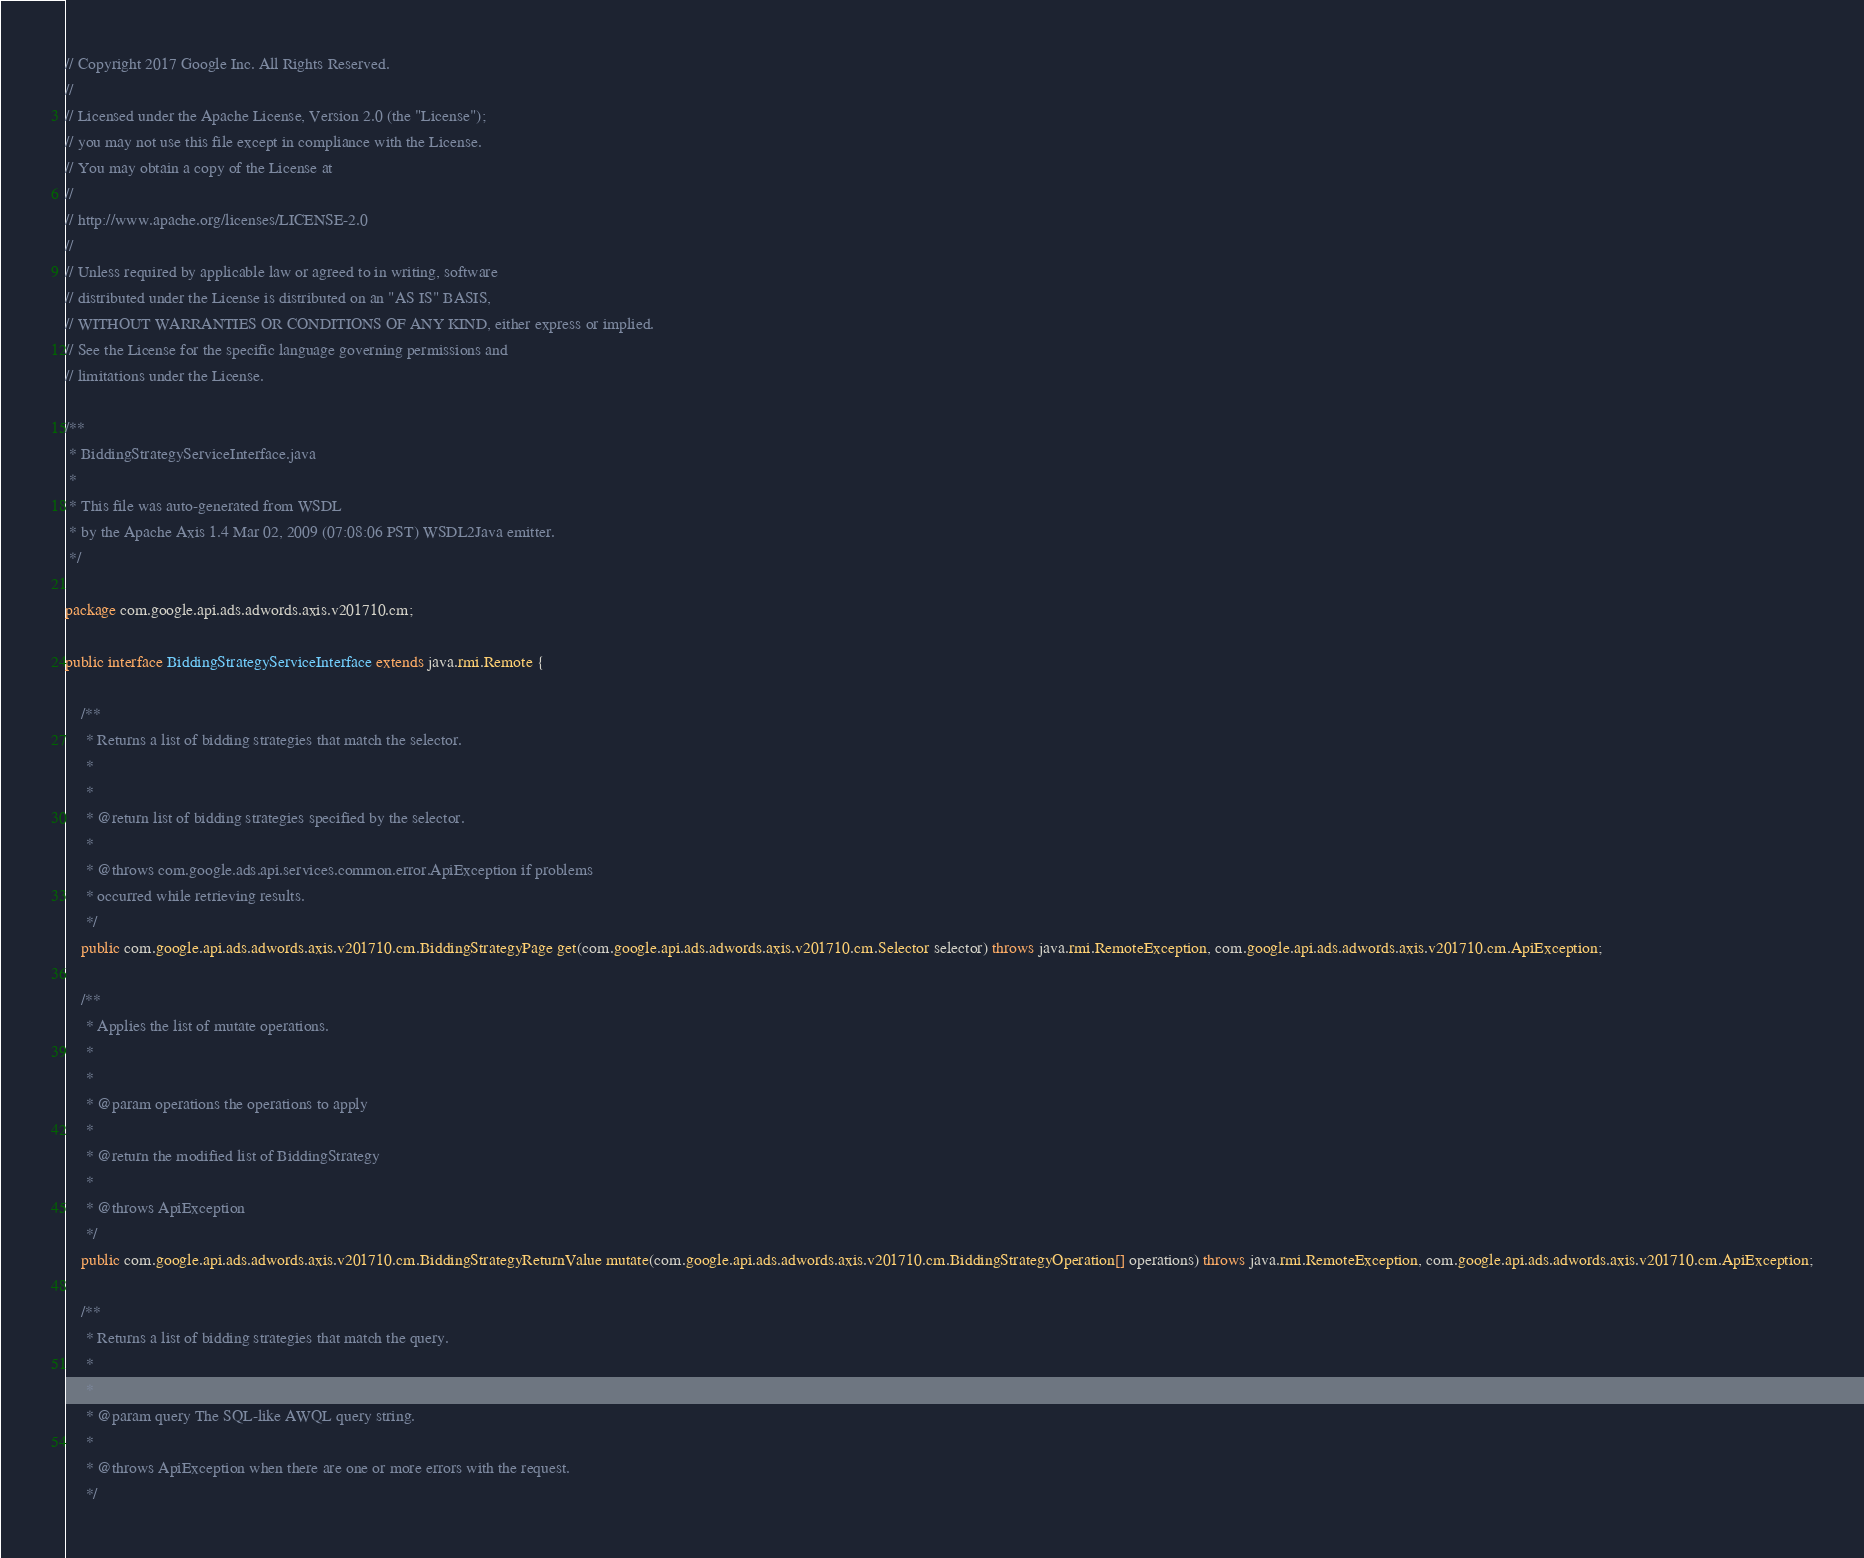Convert code to text. <code><loc_0><loc_0><loc_500><loc_500><_Java_>// Copyright 2017 Google Inc. All Rights Reserved.
//
// Licensed under the Apache License, Version 2.0 (the "License");
// you may not use this file except in compliance with the License.
// You may obtain a copy of the License at
//
// http://www.apache.org/licenses/LICENSE-2.0
//
// Unless required by applicable law or agreed to in writing, software
// distributed under the License is distributed on an "AS IS" BASIS,
// WITHOUT WARRANTIES OR CONDITIONS OF ANY KIND, either express or implied.
// See the License for the specific language governing permissions and
// limitations under the License.

/**
 * BiddingStrategyServiceInterface.java
 *
 * This file was auto-generated from WSDL
 * by the Apache Axis 1.4 Mar 02, 2009 (07:08:06 PST) WSDL2Java emitter.
 */

package com.google.api.ads.adwords.axis.v201710.cm;

public interface BiddingStrategyServiceInterface extends java.rmi.Remote {

    /**
     * Returns a list of bidding strategies that match the selector.
     * 
     *         
     * @return list of bidding strategies specified by the selector.
     *         
     * @throws com.google.ads.api.services.common.error.ApiException if problems
     * occurred while retrieving results.
     */
    public com.google.api.ads.adwords.axis.v201710.cm.BiddingStrategyPage get(com.google.api.ads.adwords.axis.v201710.cm.Selector selector) throws java.rmi.RemoteException, com.google.api.ads.adwords.axis.v201710.cm.ApiException;

    /**
     * Applies the list of mutate operations.
     *         
     *         
     * @param operations the operations to apply
     *         
     * @return the modified list of BiddingStrategy
     *         
     * @throws ApiException
     */
    public com.google.api.ads.adwords.axis.v201710.cm.BiddingStrategyReturnValue mutate(com.google.api.ads.adwords.axis.v201710.cm.BiddingStrategyOperation[] operations) throws java.rmi.RemoteException, com.google.api.ads.adwords.axis.v201710.cm.ApiException;

    /**
     * Returns a list of bidding strategies that match the query.
     *         
     *         
     * @param query The SQL-like AWQL query string.
     *         
     * @throws ApiException when there are one or more errors with the request.
     */</code> 